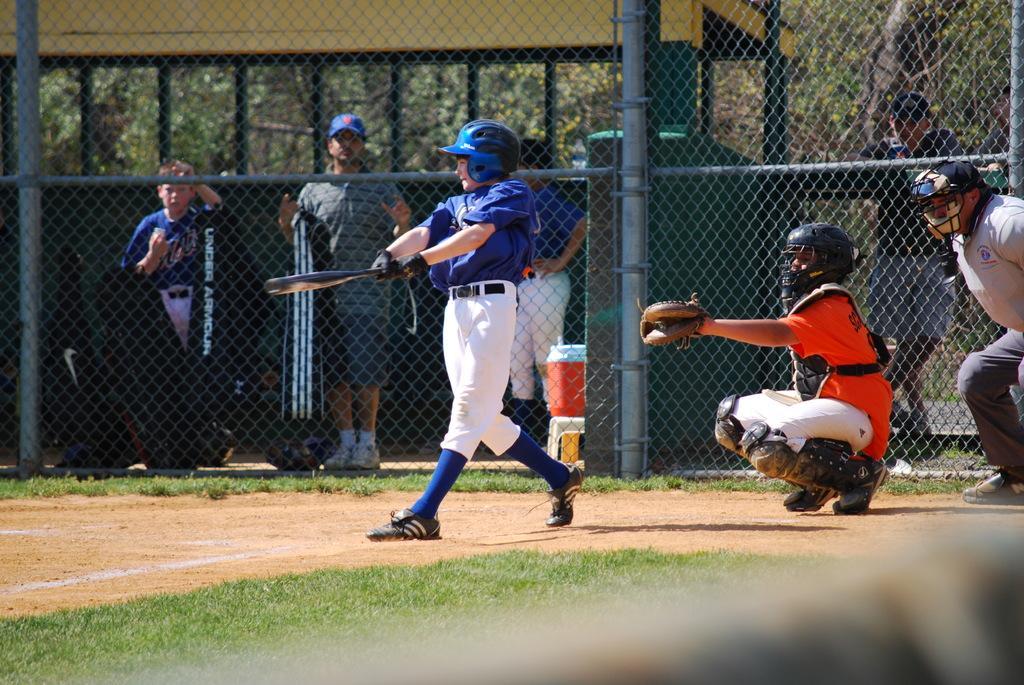In one or two sentences, can you explain what this image depicts? This image is clicked in baseball ground. There is a fence in the middle. There are trees at the top. There are some persons standing near the fence. There are 3 persons on the ground. One is wearing blue and white dress, another one is wearing orange and white dress. Most of them are wearing helmets. The one who is in the middle is holding a bat. 